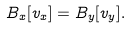Convert formula to latex. <formula><loc_0><loc_0><loc_500><loc_500>B _ { x } [ v _ { x } ] = B _ { y } [ v _ { y } ] .</formula> 